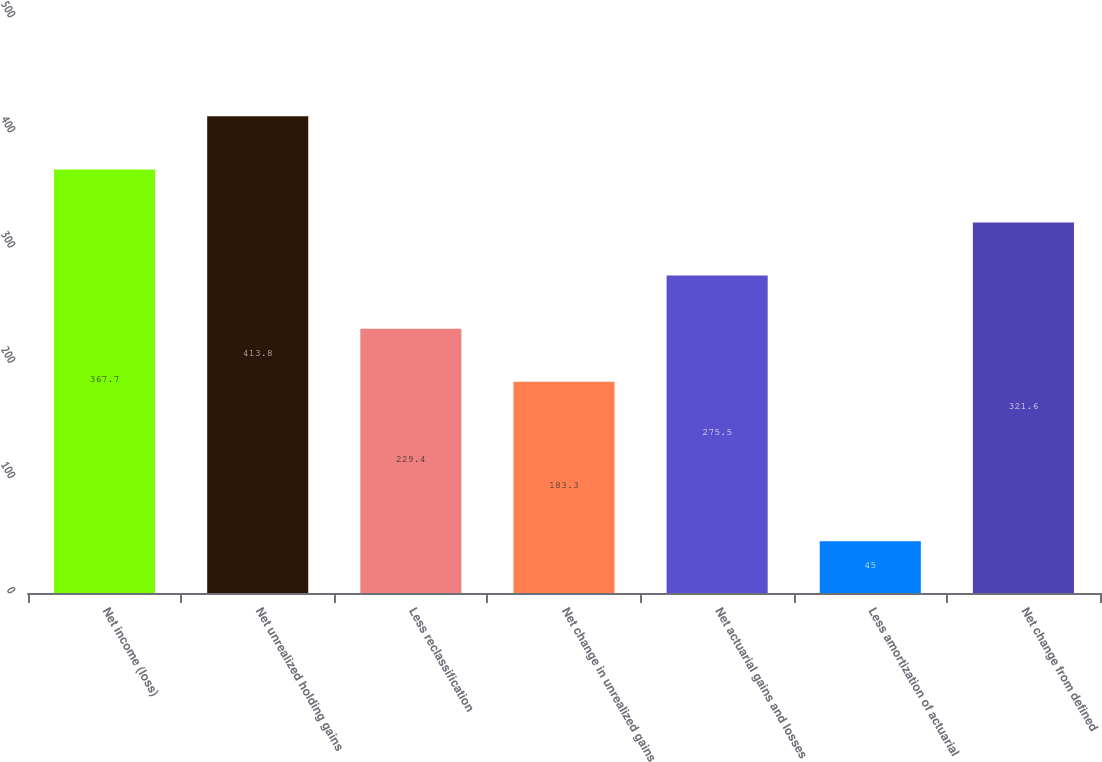Convert chart to OTSL. <chart><loc_0><loc_0><loc_500><loc_500><bar_chart><fcel>Net income (loss)<fcel>Net unrealized holding gains<fcel>Less reclassification<fcel>Net change in unrealized gains<fcel>Net actuarial gains and losses<fcel>Less amortization of actuarial<fcel>Net change from defined<nl><fcel>367.7<fcel>413.8<fcel>229.4<fcel>183.3<fcel>275.5<fcel>45<fcel>321.6<nl></chart> 